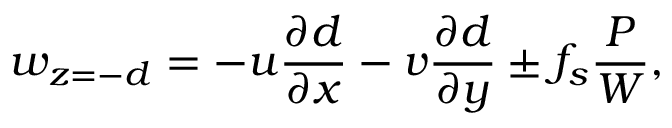Convert formula to latex. <formula><loc_0><loc_0><loc_500><loc_500>w _ { z = - d } = - u \frac { \partial d } { \partial x } - v \frac { \partial d } { \partial y } \pm f _ { s } \frac { P } { W } ,</formula> 